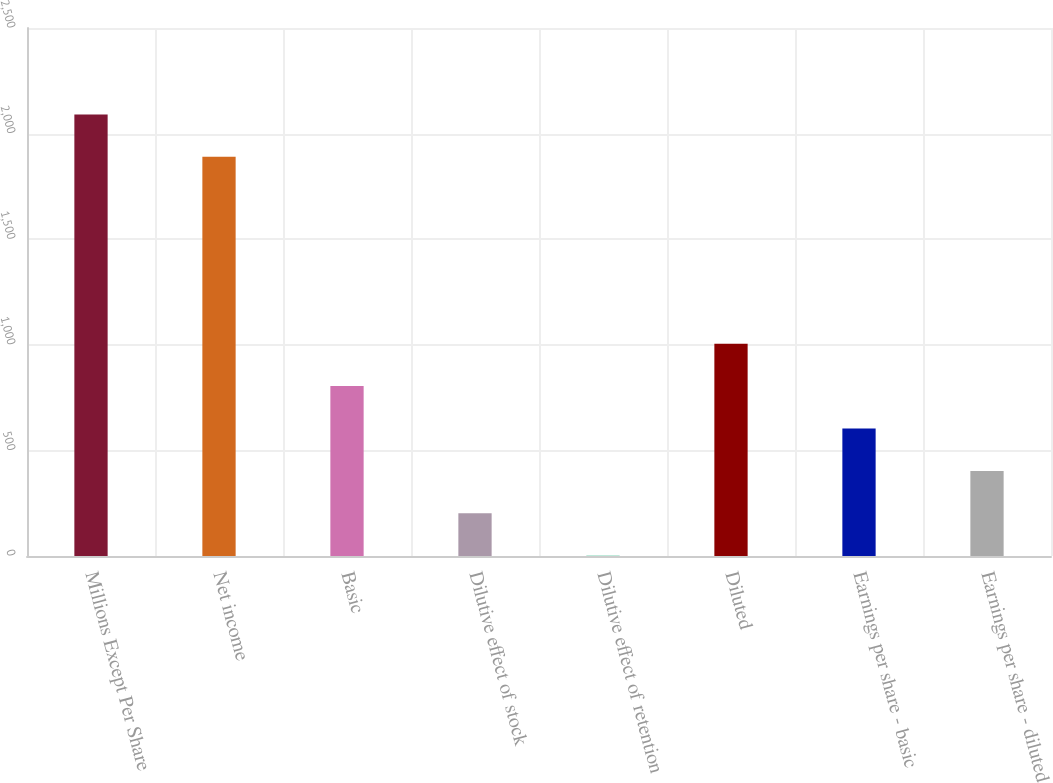Convert chart. <chart><loc_0><loc_0><loc_500><loc_500><bar_chart><fcel>Millions Except Per Share<fcel>Net income<fcel>Basic<fcel>Dilutive effect of stock<fcel>Dilutive effect of retention<fcel>Diluted<fcel>Earnings per share - basic<fcel>Earnings per share - diluted<nl><fcel>2090.77<fcel>1890<fcel>804.38<fcel>202.07<fcel>1.3<fcel>1005.15<fcel>603.61<fcel>402.84<nl></chart> 